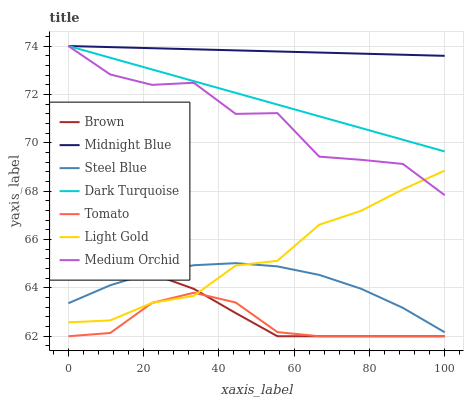Does Brown have the minimum area under the curve?
Answer yes or no. No. Does Brown have the maximum area under the curve?
Answer yes or no. No. Is Brown the smoothest?
Answer yes or no. No. Is Brown the roughest?
Answer yes or no. No. Does Midnight Blue have the lowest value?
Answer yes or no. No. Does Brown have the highest value?
Answer yes or no. No. Is Tomato less than Midnight Blue?
Answer yes or no. Yes. Is Dark Turquoise greater than Steel Blue?
Answer yes or no. Yes. Does Tomato intersect Midnight Blue?
Answer yes or no. No. 